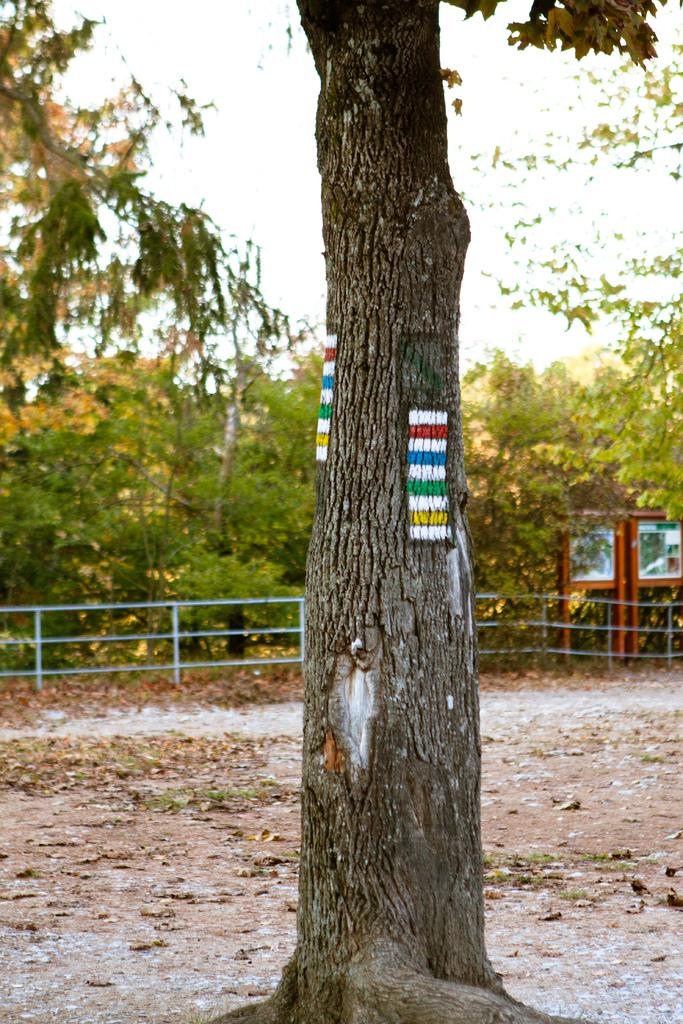What type of vegetation can be seen in the image? There are trees in the image. What type of barrier is present in the image? There is a metal fence in the image. What material are the boards made of in the image? The boards in the image are made of an unspecified material. What can be found on the ground in the image? Leaves are present on the ground in the image. What is visible in the background of the image? The sky is visible in the image. How many toes are visible on the trees in the image? Trees do not have toes, so none are visible in the image. What type of loss is depicted in the image? There is no depiction of loss in the image; it features trees, a metal fence, boards, leaves on the ground, and the sky. 